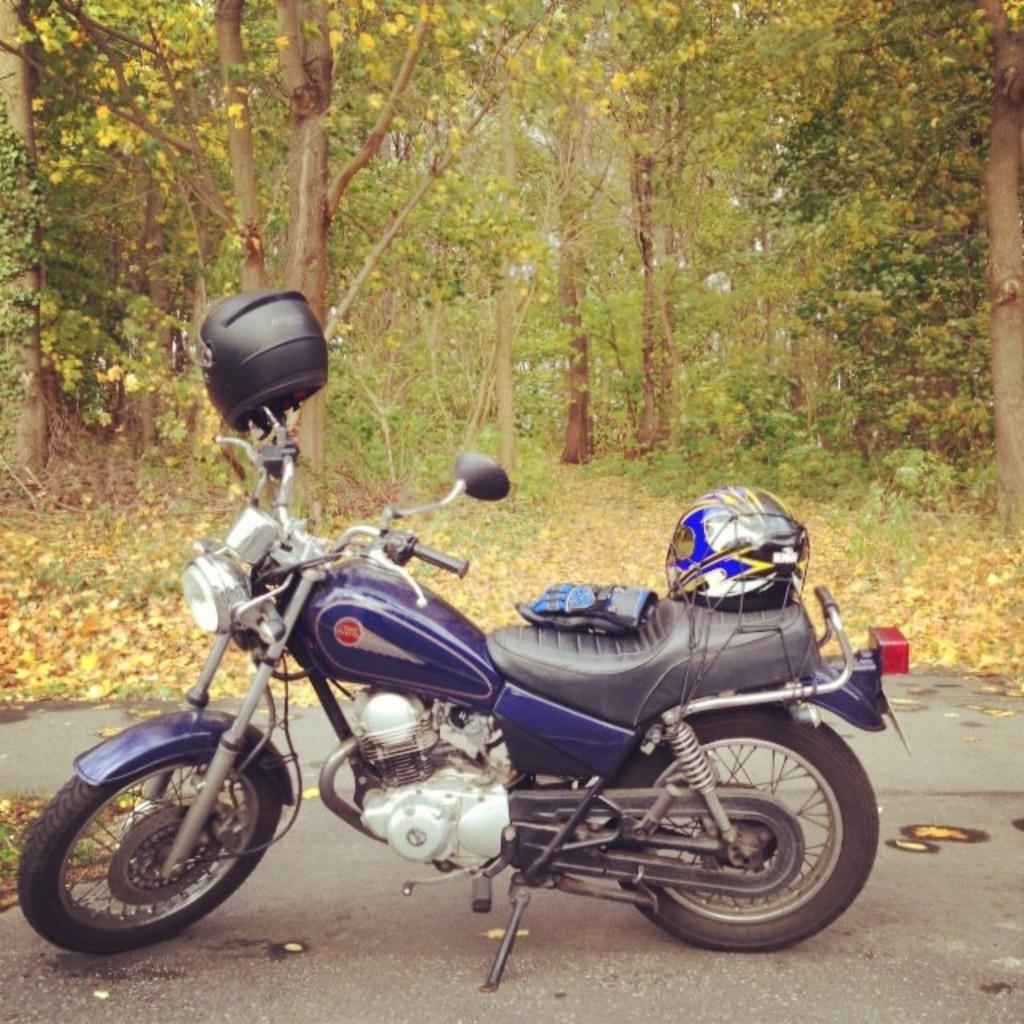What is the main subject of the image? The main subject of the image is a motorcycle. Where is the motorcycle located in the image? The motorcycle is in the middle of the image. What can be seen in the background of the image? There are trees in the background of the image. What song is the motorcycle's servant singing in the image? There is no song or servant present in the image; it features a motorcycle and trees in the background. 